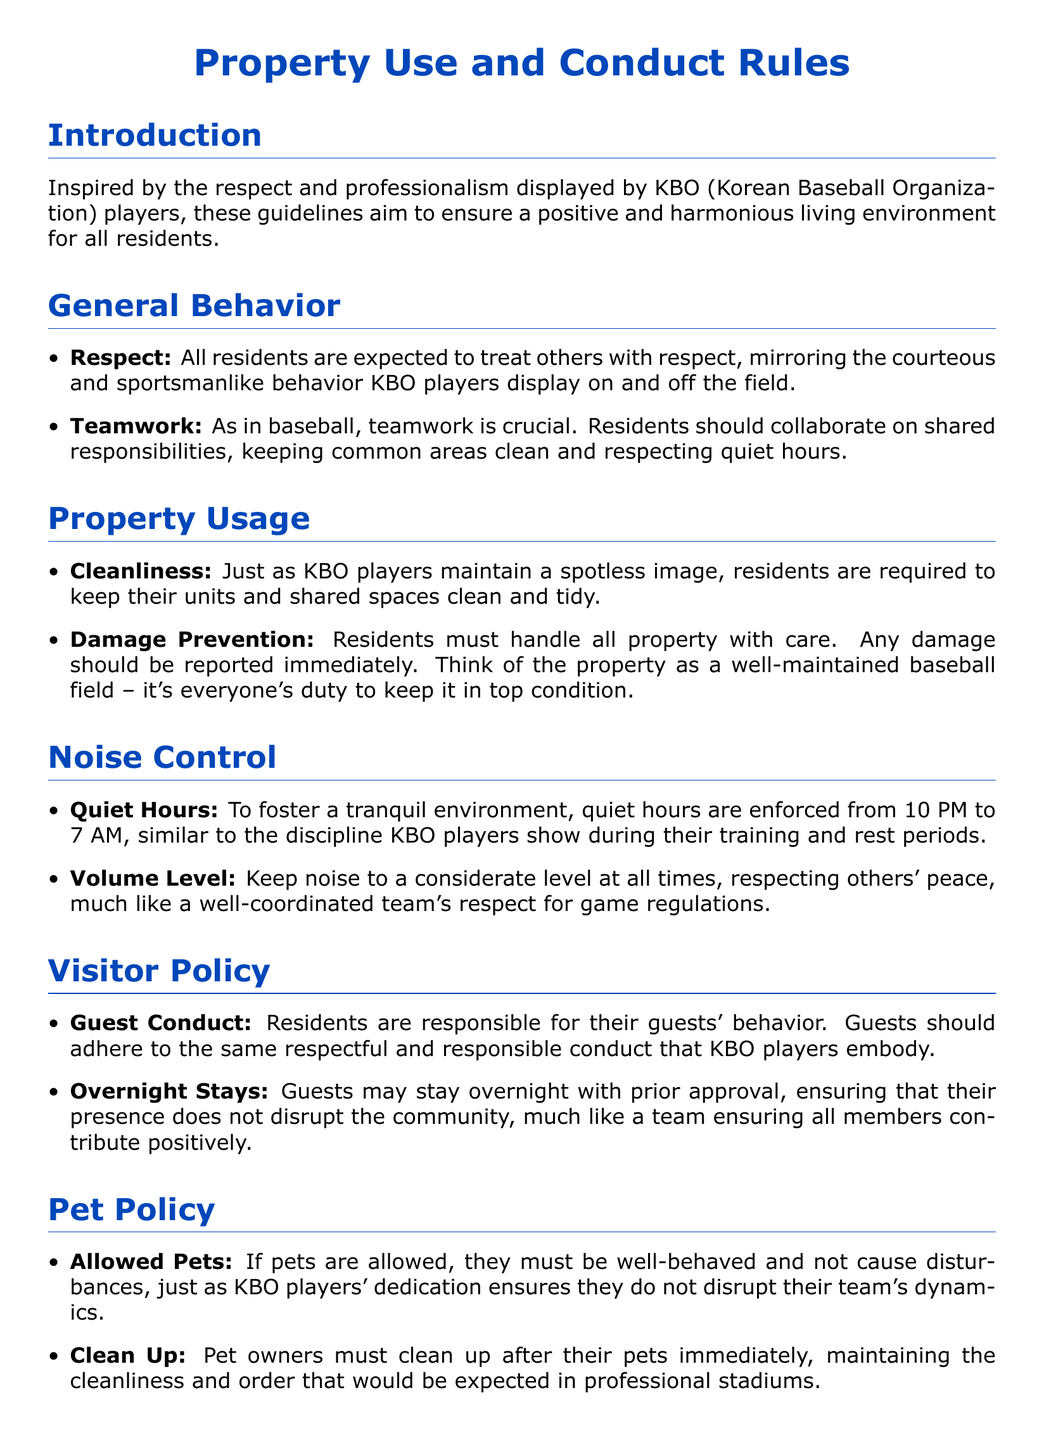What are the quiet hours? The quiet hours are from 10 PM to 7 AM, as stated in the noise control section of the document.
Answer: 10 PM to 7 AM Who is responsible for guest conduct? The document specifies that residents are responsible for their guests' behavior.
Answer: Residents What should residents do if they cause damage? Residents must report any damage immediately according to the property usage guidelines.
Answer: Report immediately What is required for overnight guest stays? Overnight stays require prior approval to ensure no disruption occurs, as mentioned in the visitor policy section.
Answer: Prior approval What color represents the title of the document? The title of the document is presented in baseball blue color.
Answer: Baseball blue How are penalties for violations described in the document? The consequences of violations may range from warnings to fines or eviction, which is comparable to penalties faced by KBO players for unsportsmanlike conduct.
Answer: Warnings to fines or eviction What behavior is expected from residents regarding cleanliness? Residents are required to keep their units and shared spaces clean and tidy, similar to standards upheld by KBO players.
Answer: Clean and tidy What must pet owners do immediately after their pets? Pet owners must clean up after their pets immediately, as noted in the pet policy section.
Answer: Clean up immediately 